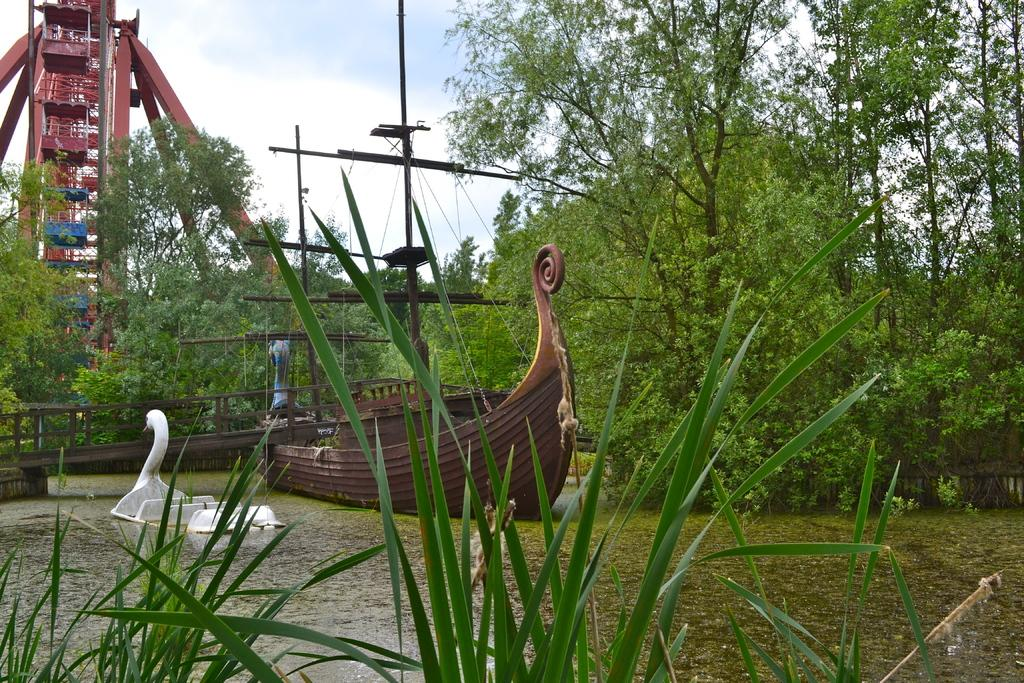What type of vegetation is in the foreground of the image? There is grass in the foreground of the image. What can be seen floating on the water surface? There are boats on the water surface. What type of amusement park ride can be seen in the background? It appears that there is a roller coaster in the background. What other natural elements are visible in the background? There are trees and the sky visible in the background. What man-made structures are present in the background? Wires and a pole are present in the background. What type of lead can be seen in the image? There is no lead present in the image. What type of cloud is visible in the image? There is no cloud visible in the image; the sky is visible in the background. 